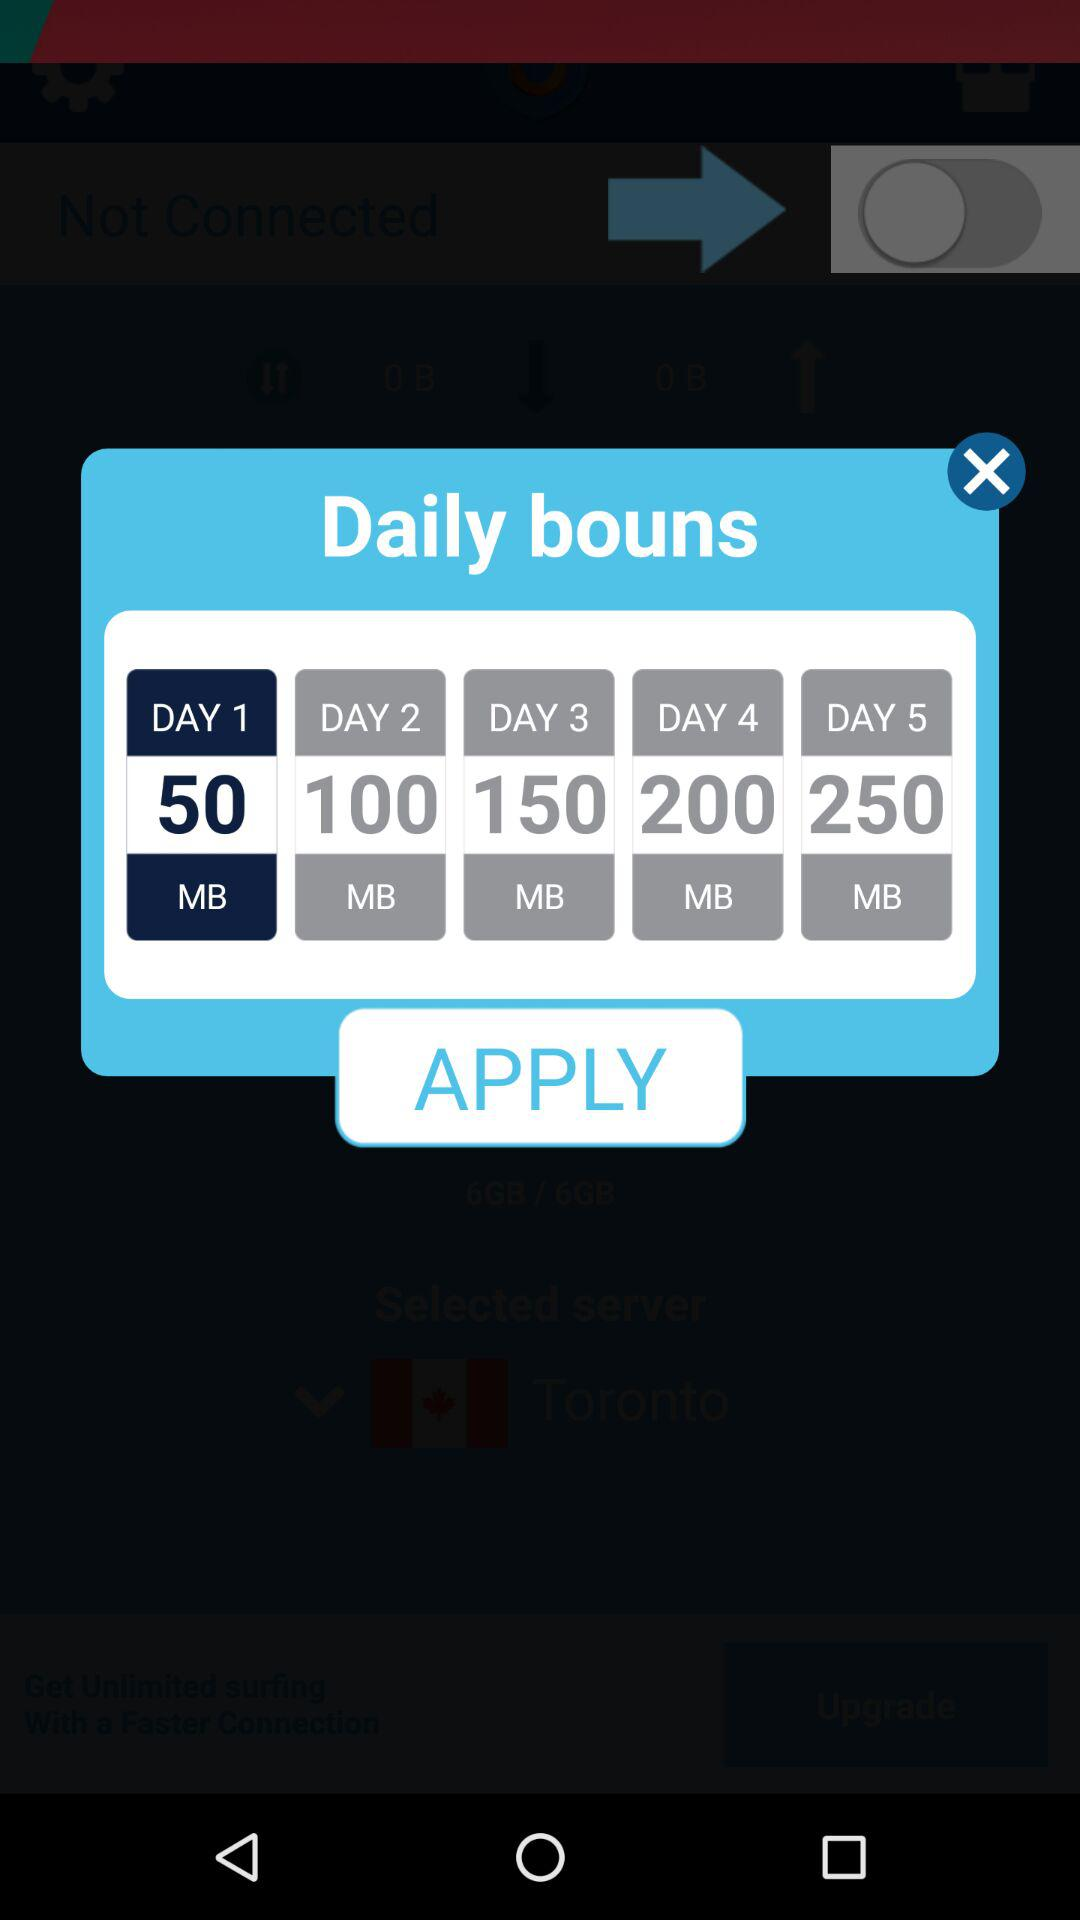How many MB of data are there for the first day of the daily bonus? There are 50 MB of data for the first day of the daily bonus. 